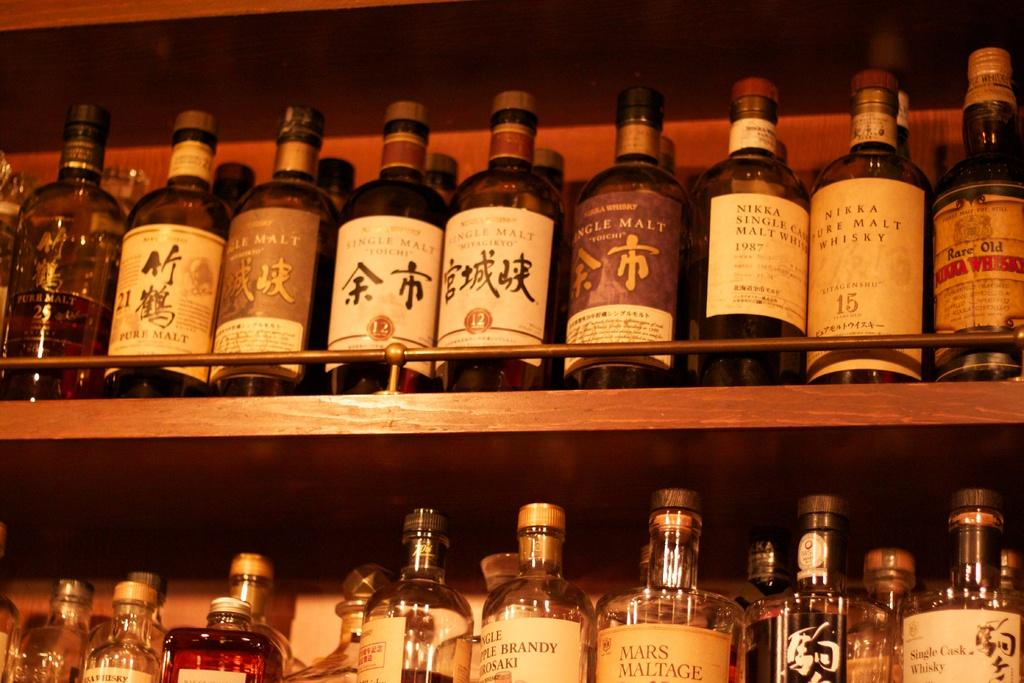<image>
Share a concise interpretation of the image provided. the word Nikka is on a 1987 bottle 